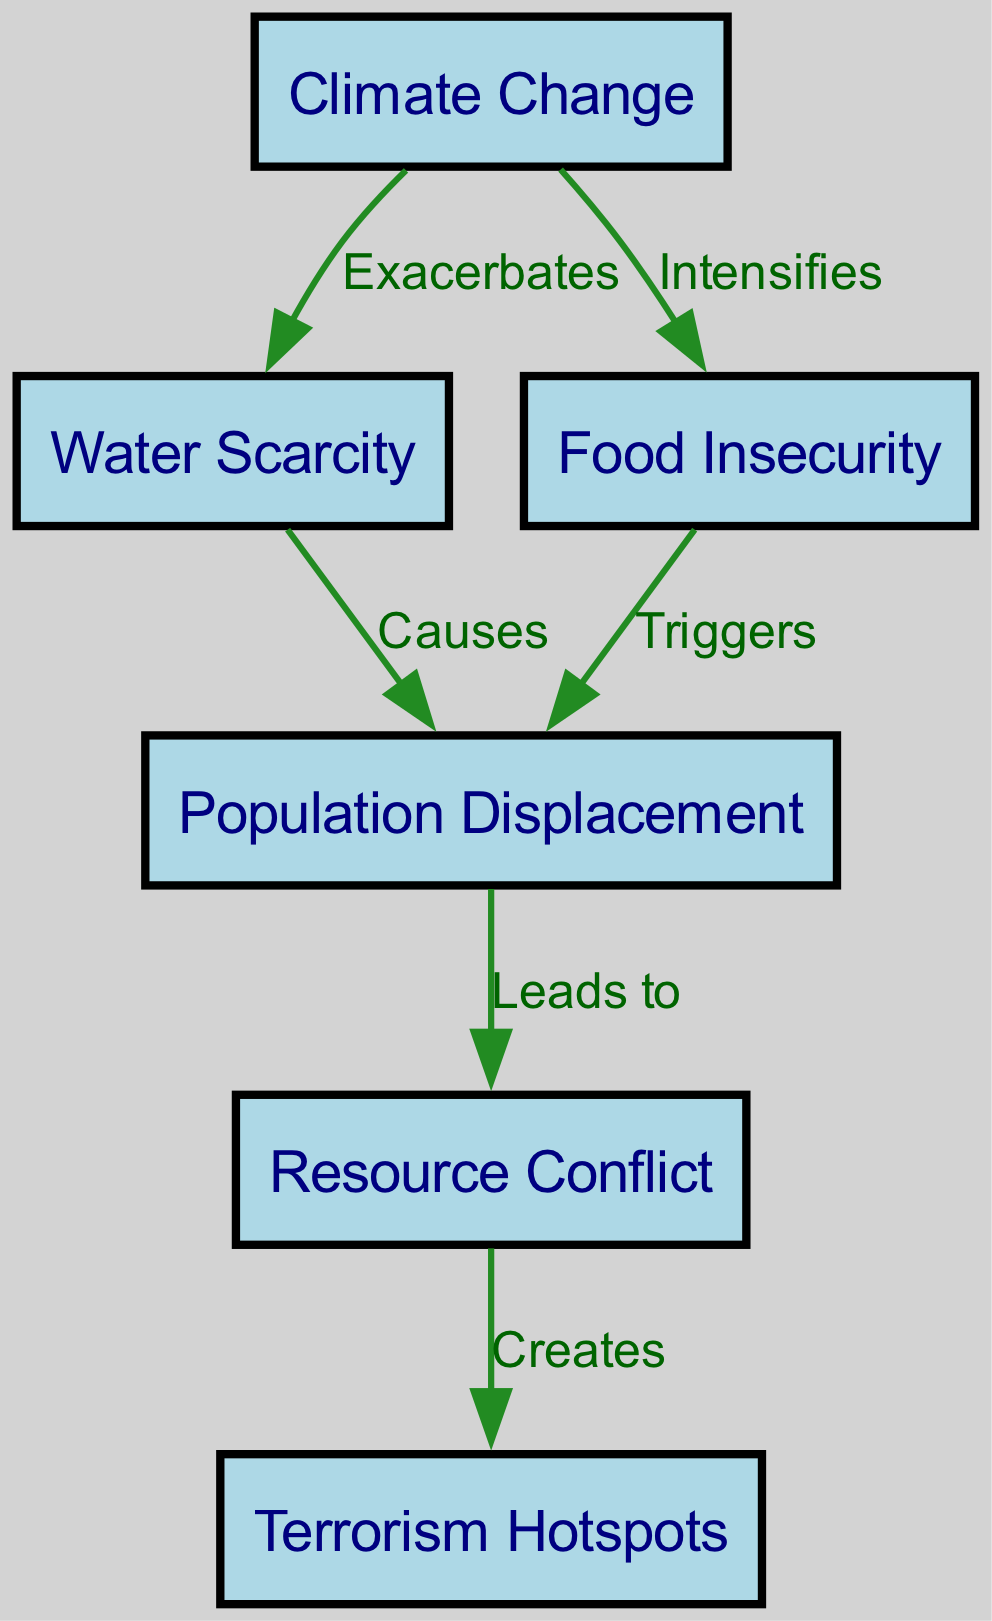What are the main effects of climate change listed in the diagram? The diagram lists two main effects of climate change: water scarcity and food insecurity. These are directly connected to the climate change node.
Answer: water scarcity, food insecurity How many nodes are present in the diagram? There are six nodes outlined in the diagram: climate change, water scarcity, food insecurity, population displacement, resource conflict, and terrorism hotspots.
Answer: six What does water scarcity cause in the diagram? Water scarcity leads to population displacement as indicated by the directed edge labeled "Causes" pointing from water scarcity to displacement.
Answer: population displacement What triggers displacement according to the diagram? According to the diagram, food insecurity triggers population displacement, as indicated by the directed edge labeled "Triggers" pointing from food insecurity to displacement.
Answer: food insecurity What relationship exists between resource conflict and terrorism hotspots? The diagram indicates that resource conflict creates terrorism hotspots, as shown by the directed edge labeled "Creates" from resource conflict to terrorism hotspots.
Answer: creates What two factors lead to resource conflict in the diagram? The two factors leading to resource conflict according to the diagram are population displacement (from both water scarcity and food insecurity) and are noted through the arrows leading to resource conflict.
Answer: population displacement How many edges connect the nodes in the diagram? There are six edges in total connecting the nodes, as reflected in the relationships shown among different factors.
Answer: six What is the process sequence from climate change to terrorism hotspots as depicted in the diagram? The sequence is: climate change exacerbates water scarcity and intensifies food insecurity; both lead to population displacement, which then leads to resource conflict, ultimately creating terrorism hotspots.
Answer: climate change → water scarcity, food insecurity → displacement → resource conflict → terrorism hotspots Which node is directly influenced by both water scarcity and food insecurity? The node directly influenced by both water scarcity and food insecurity is the population displacement node, as they both have directed edges leading to it.
Answer: population displacement 